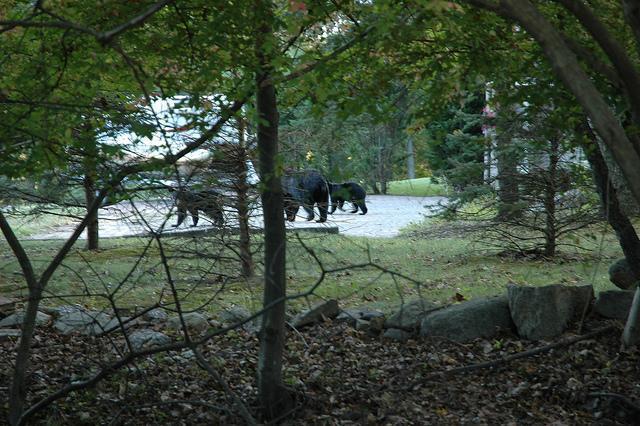How many bears are in this image?
Give a very brief answer. 3. 